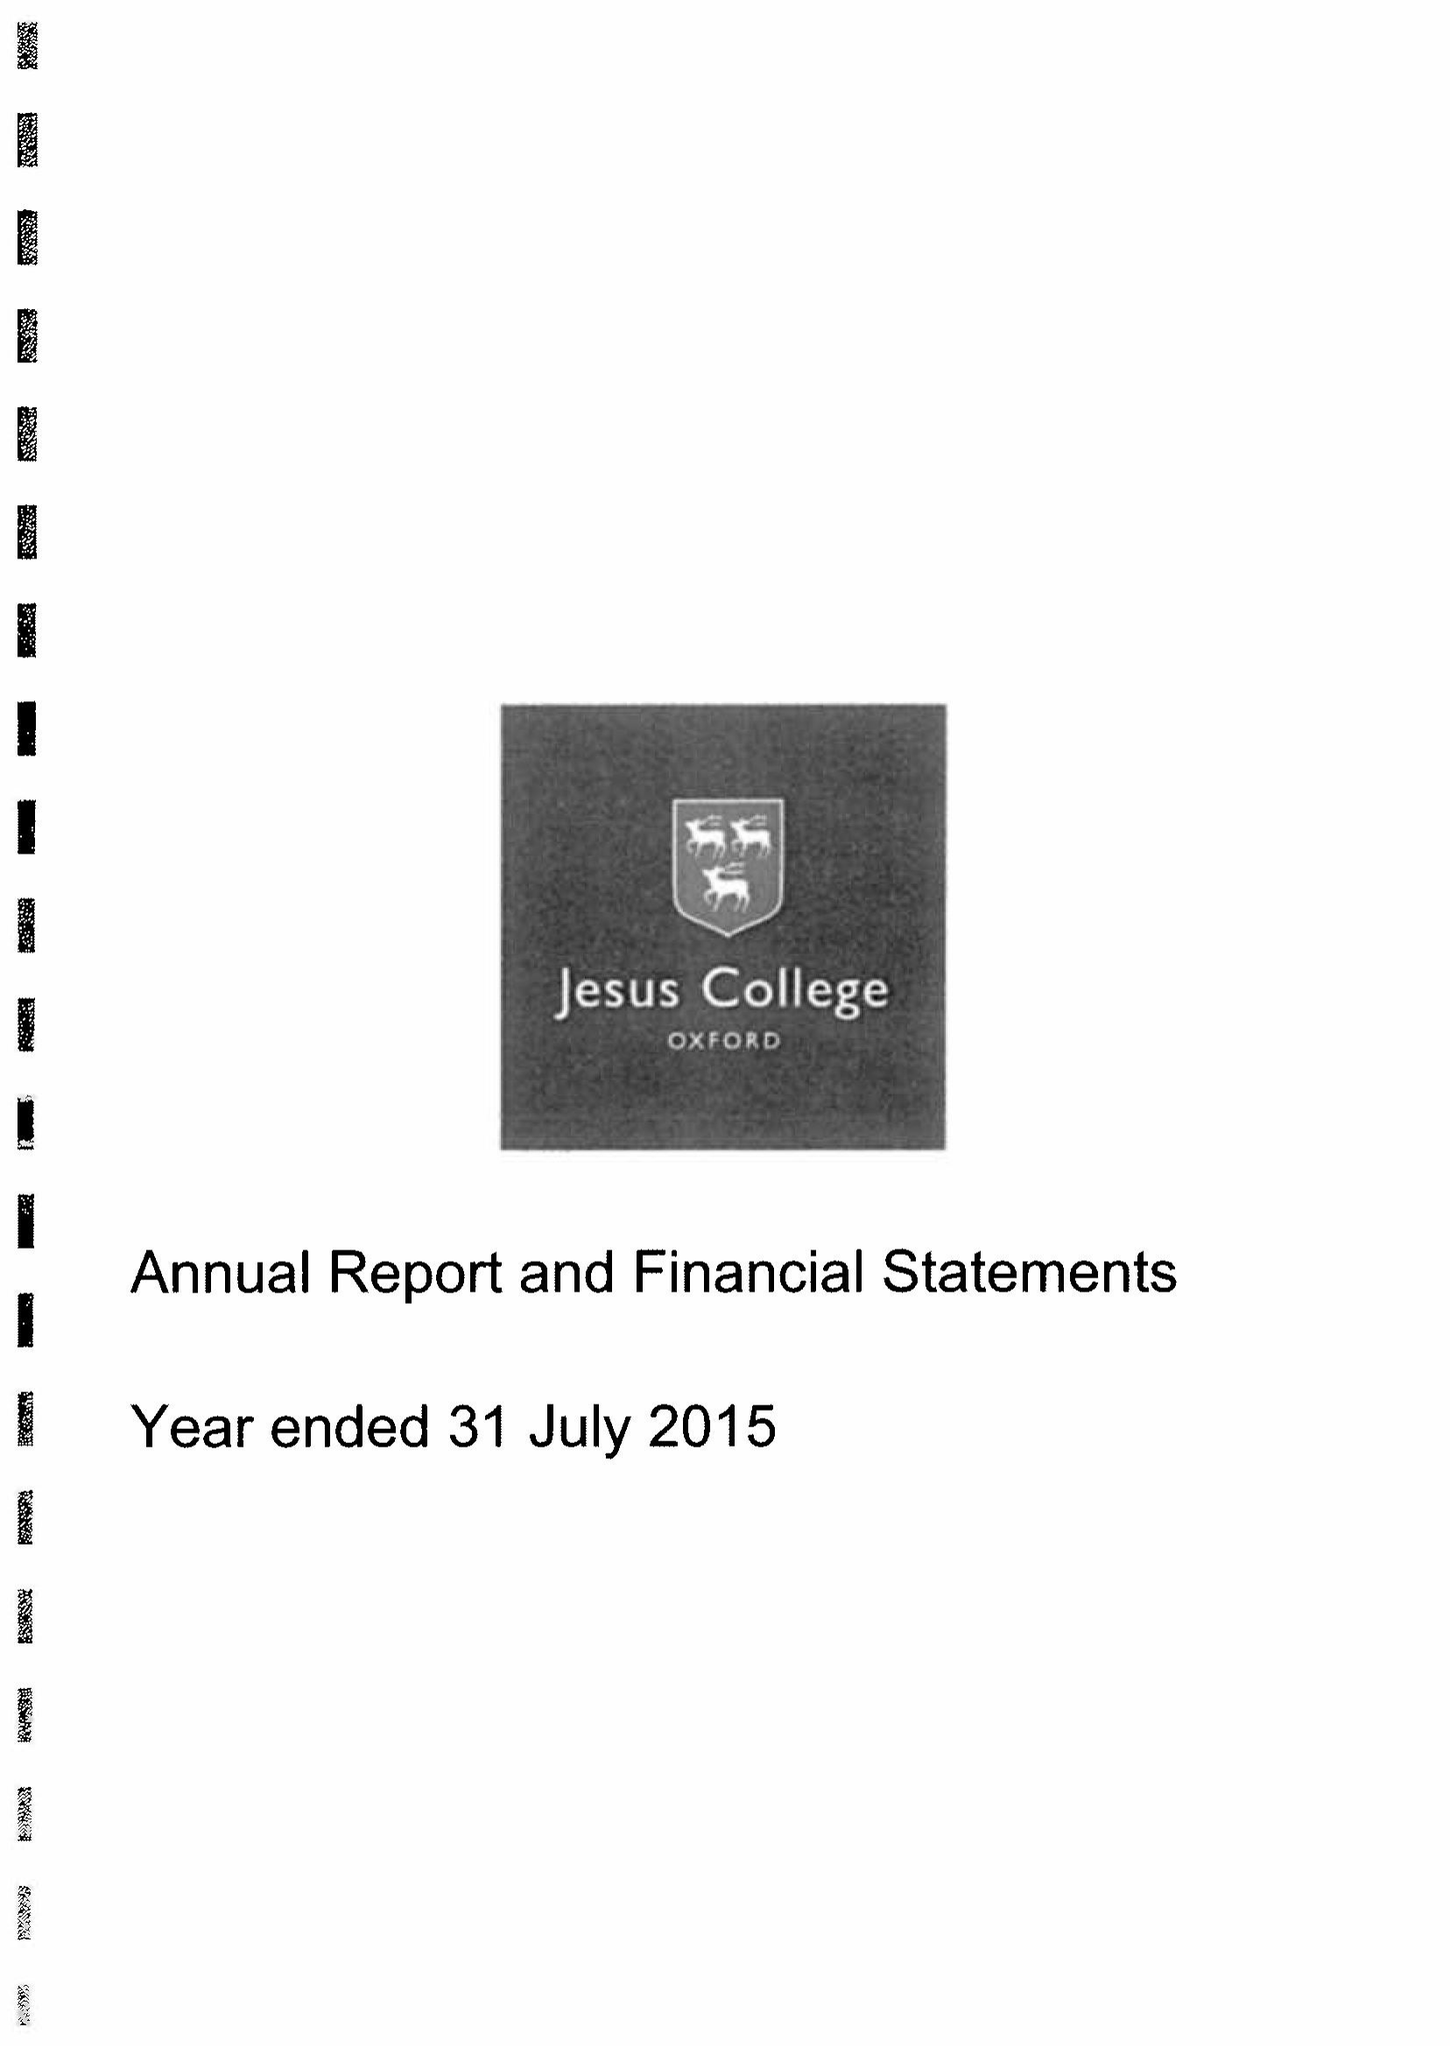What is the value for the income_annually_in_british_pounds?
Answer the question using a single word or phrase. 12396000.00 